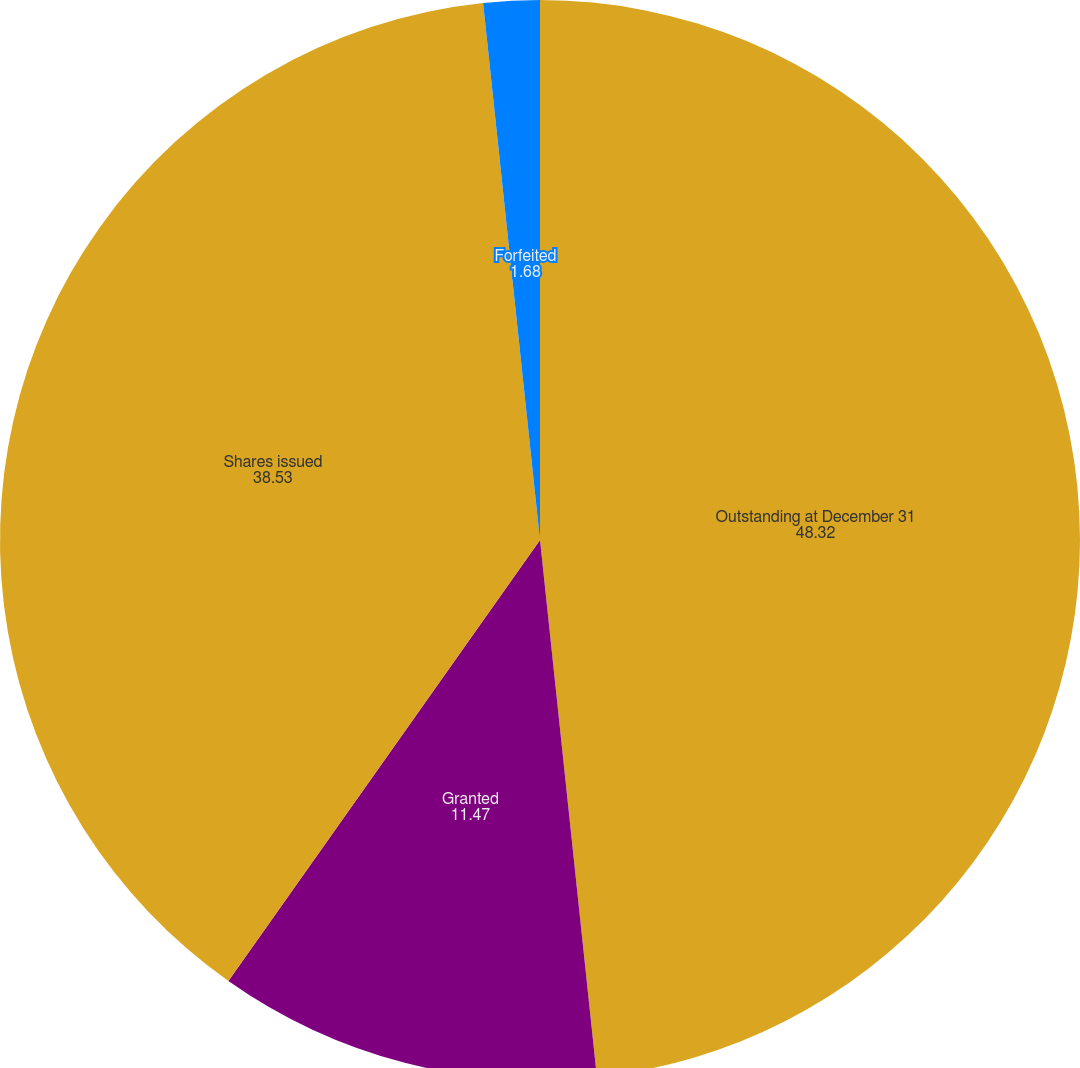Convert chart. <chart><loc_0><loc_0><loc_500><loc_500><pie_chart><fcel>Outstanding at December 31<fcel>Granted<fcel>Shares issued<fcel>Forfeited<nl><fcel>48.32%<fcel>11.47%<fcel>38.53%<fcel>1.68%<nl></chart> 